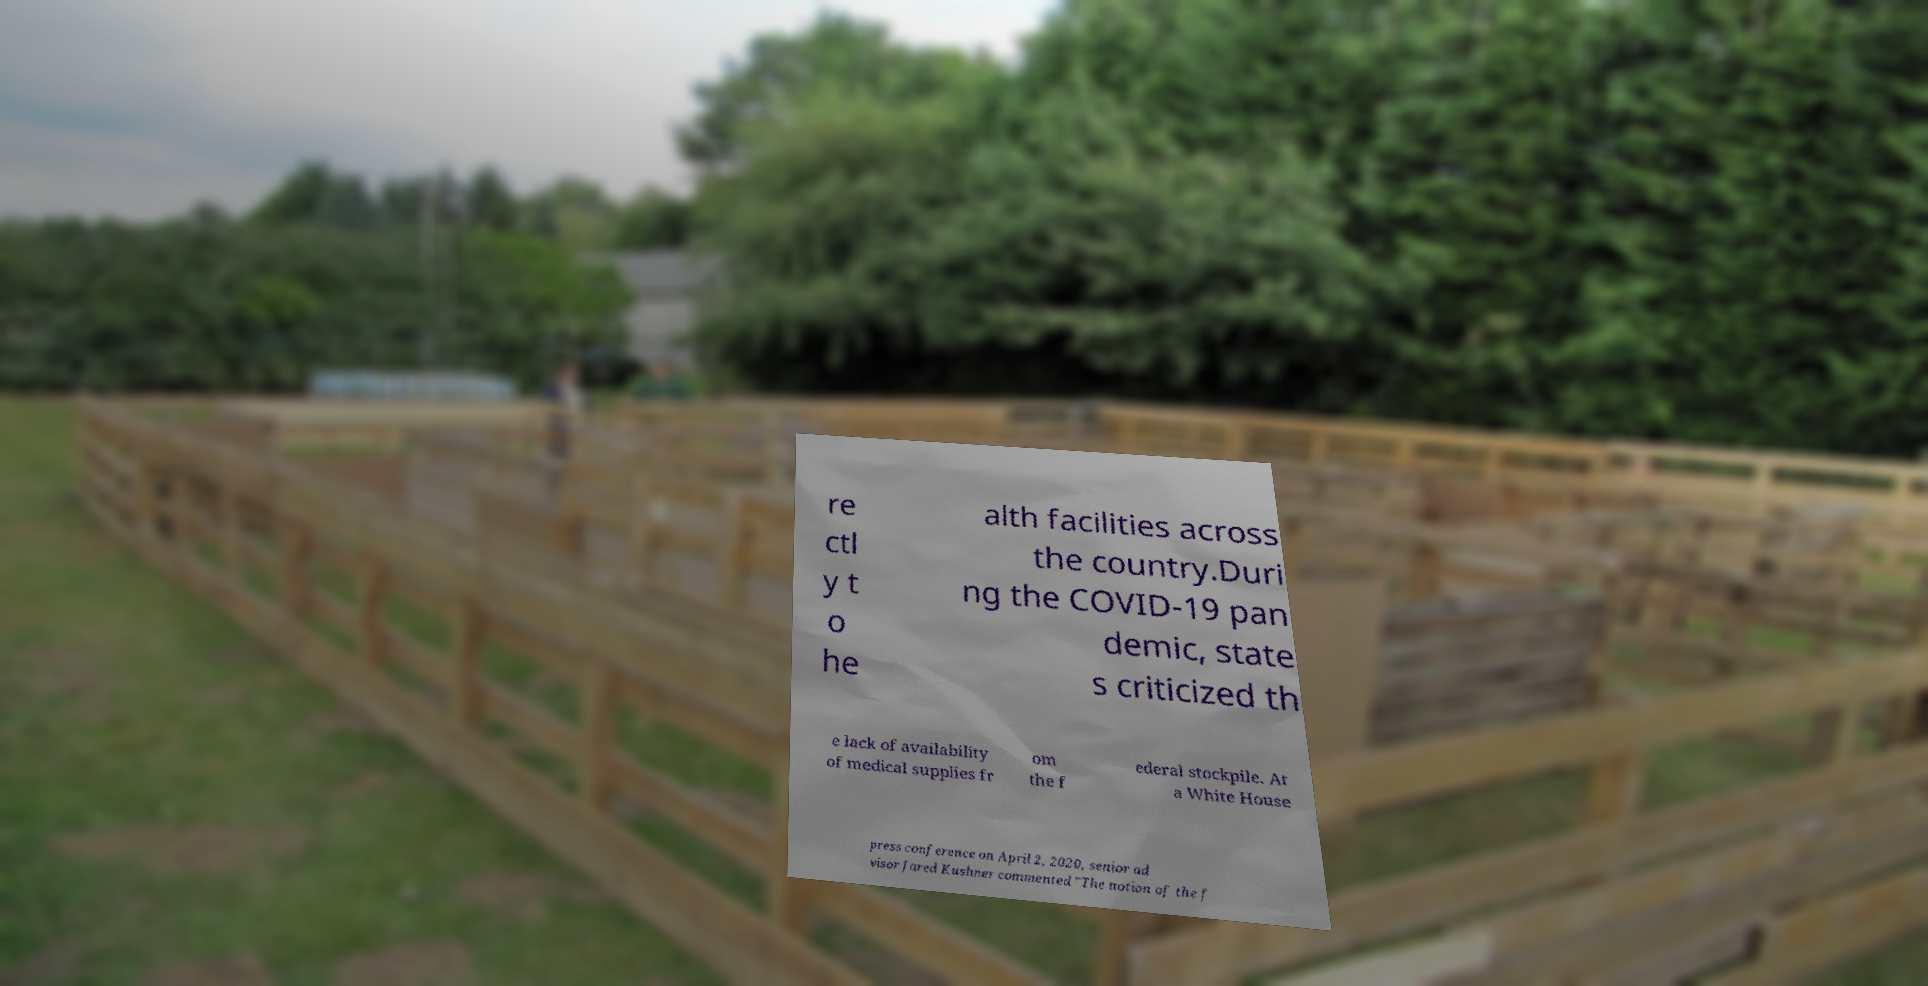For documentation purposes, I need the text within this image transcribed. Could you provide that? re ctl y t o he alth facilities across the country.Duri ng the COVID-19 pan demic, state s criticized th e lack of availability of medical supplies fr om the f ederal stockpile. At a White House press conference on April 2, 2020, senior ad visor Jared Kushner commented "The notion of the f 